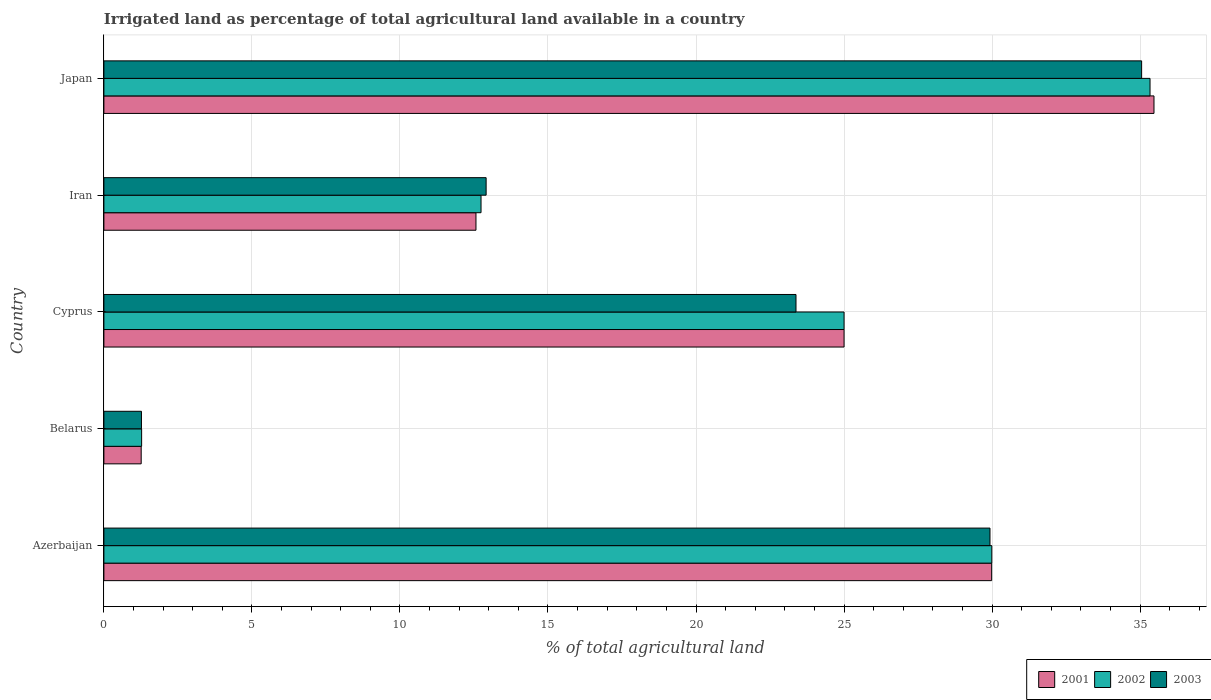How many different coloured bars are there?
Provide a succinct answer. 3. Are the number of bars on each tick of the Y-axis equal?
Provide a succinct answer. Yes. How many bars are there on the 5th tick from the top?
Keep it short and to the point. 3. How many bars are there on the 3rd tick from the bottom?
Your answer should be very brief. 3. What is the label of the 1st group of bars from the top?
Ensure brevity in your answer.  Japan. In how many cases, is the number of bars for a given country not equal to the number of legend labels?
Provide a short and direct response. 0. What is the percentage of irrigated land in 2003 in Iran?
Offer a very short reply. 12.91. Across all countries, what is the maximum percentage of irrigated land in 2002?
Your answer should be compact. 35.33. Across all countries, what is the minimum percentage of irrigated land in 2002?
Provide a succinct answer. 1.27. In which country was the percentage of irrigated land in 2003 minimum?
Give a very brief answer. Belarus. What is the total percentage of irrigated land in 2002 in the graph?
Your response must be concise. 104.34. What is the difference between the percentage of irrigated land in 2001 in Azerbaijan and that in Belarus?
Provide a short and direct response. 28.73. What is the difference between the percentage of irrigated land in 2003 in Belarus and the percentage of irrigated land in 2002 in Iran?
Keep it short and to the point. -11.47. What is the average percentage of irrigated land in 2001 per country?
Your response must be concise. 20.86. In how many countries, is the percentage of irrigated land in 2003 greater than 33 %?
Make the answer very short. 1. What is the ratio of the percentage of irrigated land in 2003 in Iran to that in Japan?
Offer a very short reply. 0.37. Is the difference between the percentage of irrigated land in 2002 in Cyprus and Japan greater than the difference between the percentage of irrigated land in 2001 in Cyprus and Japan?
Provide a succinct answer. Yes. What is the difference between the highest and the second highest percentage of irrigated land in 2002?
Keep it short and to the point. 5.34. What is the difference between the highest and the lowest percentage of irrigated land in 2003?
Your response must be concise. 33.78. In how many countries, is the percentage of irrigated land in 2002 greater than the average percentage of irrigated land in 2002 taken over all countries?
Make the answer very short. 3. What does the 2nd bar from the top in Belarus represents?
Offer a very short reply. 2002. What does the 1st bar from the bottom in Iran represents?
Make the answer very short. 2001. How many bars are there?
Your answer should be very brief. 15. Are all the bars in the graph horizontal?
Your response must be concise. Yes. Are the values on the major ticks of X-axis written in scientific E-notation?
Provide a succinct answer. No. Does the graph contain any zero values?
Make the answer very short. No. How many legend labels are there?
Offer a very short reply. 3. How are the legend labels stacked?
Make the answer very short. Horizontal. What is the title of the graph?
Ensure brevity in your answer.  Irrigated land as percentage of total agricultural land available in a country. What is the label or title of the X-axis?
Your answer should be compact. % of total agricultural land. What is the label or title of the Y-axis?
Ensure brevity in your answer.  Country. What is the % of total agricultural land in 2001 in Azerbaijan?
Your answer should be compact. 29.99. What is the % of total agricultural land in 2002 in Azerbaijan?
Offer a terse response. 29.99. What is the % of total agricultural land in 2003 in Azerbaijan?
Your answer should be very brief. 29.93. What is the % of total agricultural land of 2001 in Belarus?
Offer a very short reply. 1.26. What is the % of total agricultural land in 2002 in Belarus?
Offer a very short reply. 1.27. What is the % of total agricultural land of 2003 in Belarus?
Offer a very short reply. 1.27. What is the % of total agricultural land in 2002 in Cyprus?
Make the answer very short. 25. What is the % of total agricultural land of 2003 in Cyprus?
Your response must be concise. 23.38. What is the % of total agricultural land of 2001 in Iran?
Your answer should be compact. 12.57. What is the % of total agricultural land in 2002 in Iran?
Your answer should be compact. 12.74. What is the % of total agricultural land in 2003 in Iran?
Your answer should be very brief. 12.91. What is the % of total agricultural land of 2001 in Japan?
Provide a short and direct response. 35.47. What is the % of total agricultural land in 2002 in Japan?
Ensure brevity in your answer.  35.33. What is the % of total agricultural land of 2003 in Japan?
Ensure brevity in your answer.  35.05. Across all countries, what is the maximum % of total agricultural land of 2001?
Your answer should be compact. 35.47. Across all countries, what is the maximum % of total agricultural land of 2002?
Your answer should be very brief. 35.33. Across all countries, what is the maximum % of total agricultural land in 2003?
Your answer should be compact. 35.05. Across all countries, what is the minimum % of total agricultural land in 2001?
Your answer should be very brief. 1.26. Across all countries, what is the minimum % of total agricultural land in 2002?
Ensure brevity in your answer.  1.27. Across all countries, what is the minimum % of total agricultural land in 2003?
Make the answer very short. 1.27. What is the total % of total agricultural land of 2001 in the graph?
Keep it short and to the point. 104.28. What is the total % of total agricultural land in 2002 in the graph?
Offer a very short reply. 104.34. What is the total % of total agricultural land of 2003 in the graph?
Your answer should be compact. 102.54. What is the difference between the % of total agricultural land of 2001 in Azerbaijan and that in Belarus?
Provide a succinct answer. 28.73. What is the difference between the % of total agricultural land in 2002 in Azerbaijan and that in Belarus?
Offer a very short reply. 28.72. What is the difference between the % of total agricultural land in 2003 in Azerbaijan and that in Belarus?
Make the answer very short. 28.66. What is the difference between the % of total agricultural land in 2001 in Azerbaijan and that in Cyprus?
Offer a very short reply. 4.99. What is the difference between the % of total agricultural land in 2002 in Azerbaijan and that in Cyprus?
Keep it short and to the point. 4.99. What is the difference between the % of total agricultural land in 2003 in Azerbaijan and that in Cyprus?
Offer a very short reply. 6.55. What is the difference between the % of total agricultural land of 2001 in Azerbaijan and that in Iran?
Provide a succinct answer. 17.42. What is the difference between the % of total agricultural land in 2002 in Azerbaijan and that in Iran?
Offer a very short reply. 17.25. What is the difference between the % of total agricultural land in 2003 in Azerbaijan and that in Iran?
Provide a succinct answer. 17.02. What is the difference between the % of total agricultural land of 2001 in Azerbaijan and that in Japan?
Provide a short and direct response. -5.48. What is the difference between the % of total agricultural land of 2002 in Azerbaijan and that in Japan?
Keep it short and to the point. -5.34. What is the difference between the % of total agricultural land in 2003 in Azerbaijan and that in Japan?
Provide a short and direct response. -5.12. What is the difference between the % of total agricultural land in 2001 in Belarus and that in Cyprus?
Your response must be concise. -23.74. What is the difference between the % of total agricultural land in 2002 in Belarus and that in Cyprus?
Provide a succinct answer. -23.73. What is the difference between the % of total agricultural land of 2003 in Belarus and that in Cyprus?
Offer a terse response. -22.11. What is the difference between the % of total agricultural land in 2001 in Belarus and that in Iran?
Provide a short and direct response. -11.31. What is the difference between the % of total agricultural land of 2002 in Belarus and that in Iran?
Keep it short and to the point. -11.46. What is the difference between the % of total agricultural land in 2003 in Belarus and that in Iran?
Keep it short and to the point. -11.64. What is the difference between the % of total agricultural land of 2001 in Belarus and that in Japan?
Offer a terse response. -34.21. What is the difference between the % of total agricultural land in 2002 in Belarus and that in Japan?
Your answer should be very brief. -34.06. What is the difference between the % of total agricultural land of 2003 in Belarus and that in Japan?
Provide a short and direct response. -33.78. What is the difference between the % of total agricultural land in 2001 in Cyprus and that in Iran?
Provide a short and direct response. 12.43. What is the difference between the % of total agricultural land of 2002 in Cyprus and that in Iran?
Keep it short and to the point. 12.26. What is the difference between the % of total agricultural land of 2003 in Cyprus and that in Iran?
Keep it short and to the point. 10.47. What is the difference between the % of total agricultural land in 2001 in Cyprus and that in Japan?
Your answer should be compact. -10.47. What is the difference between the % of total agricultural land of 2002 in Cyprus and that in Japan?
Provide a succinct answer. -10.33. What is the difference between the % of total agricultural land of 2003 in Cyprus and that in Japan?
Give a very brief answer. -11.67. What is the difference between the % of total agricultural land of 2001 in Iran and that in Japan?
Ensure brevity in your answer.  -22.9. What is the difference between the % of total agricultural land in 2002 in Iran and that in Japan?
Keep it short and to the point. -22.6. What is the difference between the % of total agricultural land of 2003 in Iran and that in Japan?
Your answer should be very brief. -22.14. What is the difference between the % of total agricultural land of 2001 in Azerbaijan and the % of total agricultural land of 2002 in Belarus?
Provide a succinct answer. 28.71. What is the difference between the % of total agricultural land of 2001 in Azerbaijan and the % of total agricultural land of 2003 in Belarus?
Offer a terse response. 28.72. What is the difference between the % of total agricultural land of 2002 in Azerbaijan and the % of total agricultural land of 2003 in Belarus?
Offer a very short reply. 28.72. What is the difference between the % of total agricultural land in 2001 in Azerbaijan and the % of total agricultural land in 2002 in Cyprus?
Give a very brief answer. 4.99. What is the difference between the % of total agricultural land in 2001 in Azerbaijan and the % of total agricultural land in 2003 in Cyprus?
Offer a very short reply. 6.61. What is the difference between the % of total agricultural land of 2002 in Azerbaijan and the % of total agricultural land of 2003 in Cyprus?
Offer a very short reply. 6.61. What is the difference between the % of total agricultural land in 2001 in Azerbaijan and the % of total agricultural land in 2002 in Iran?
Your answer should be very brief. 17.25. What is the difference between the % of total agricultural land of 2001 in Azerbaijan and the % of total agricultural land of 2003 in Iran?
Ensure brevity in your answer.  17.08. What is the difference between the % of total agricultural land in 2002 in Azerbaijan and the % of total agricultural land in 2003 in Iran?
Your response must be concise. 17.08. What is the difference between the % of total agricultural land in 2001 in Azerbaijan and the % of total agricultural land in 2002 in Japan?
Provide a short and direct response. -5.35. What is the difference between the % of total agricultural land in 2001 in Azerbaijan and the % of total agricultural land in 2003 in Japan?
Provide a succinct answer. -5.07. What is the difference between the % of total agricultural land of 2002 in Azerbaijan and the % of total agricultural land of 2003 in Japan?
Your answer should be very brief. -5.06. What is the difference between the % of total agricultural land of 2001 in Belarus and the % of total agricultural land of 2002 in Cyprus?
Your answer should be compact. -23.74. What is the difference between the % of total agricultural land in 2001 in Belarus and the % of total agricultural land in 2003 in Cyprus?
Your answer should be very brief. -22.12. What is the difference between the % of total agricultural land of 2002 in Belarus and the % of total agricultural land of 2003 in Cyprus?
Your answer should be very brief. -22.1. What is the difference between the % of total agricultural land of 2001 in Belarus and the % of total agricultural land of 2002 in Iran?
Provide a short and direct response. -11.48. What is the difference between the % of total agricultural land of 2001 in Belarus and the % of total agricultural land of 2003 in Iran?
Your answer should be compact. -11.65. What is the difference between the % of total agricultural land in 2002 in Belarus and the % of total agricultural land in 2003 in Iran?
Your response must be concise. -11.64. What is the difference between the % of total agricultural land of 2001 in Belarus and the % of total agricultural land of 2002 in Japan?
Your answer should be very brief. -34.08. What is the difference between the % of total agricultural land in 2001 in Belarus and the % of total agricultural land in 2003 in Japan?
Offer a terse response. -33.79. What is the difference between the % of total agricultural land in 2002 in Belarus and the % of total agricultural land in 2003 in Japan?
Provide a short and direct response. -33.78. What is the difference between the % of total agricultural land in 2001 in Cyprus and the % of total agricultural land in 2002 in Iran?
Provide a short and direct response. 12.26. What is the difference between the % of total agricultural land in 2001 in Cyprus and the % of total agricultural land in 2003 in Iran?
Make the answer very short. 12.09. What is the difference between the % of total agricultural land of 2002 in Cyprus and the % of total agricultural land of 2003 in Iran?
Your answer should be compact. 12.09. What is the difference between the % of total agricultural land of 2001 in Cyprus and the % of total agricultural land of 2002 in Japan?
Your answer should be very brief. -10.33. What is the difference between the % of total agricultural land of 2001 in Cyprus and the % of total agricultural land of 2003 in Japan?
Make the answer very short. -10.05. What is the difference between the % of total agricultural land of 2002 in Cyprus and the % of total agricultural land of 2003 in Japan?
Your answer should be very brief. -10.05. What is the difference between the % of total agricultural land of 2001 in Iran and the % of total agricultural land of 2002 in Japan?
Offer a terse response. -22.77. What is the difference between the % of total agricultural land of 2001 in Iran and the % of total agricultural land of 2003 in Japan?
Offer a very short reply. -22.48. What is the difference between the % of total agricultural land in 2002 in Iran and the % of total agricultural land in 2003 in Japan?
Your answer should be compact. -22.31. What is the average % of total agricultural land of 2001 per country?
Your response must be concise. 20.86. What is the average % of total agricultural land in 2002 per country?
Your response must be concise. 20.87. What is the average % of total agricultural land in 2003 per country?
Your response must be concise. 20.51. What is the difference between the % of total agricultural land of 2001 and % of total agricultural land of 2002 in Azerbaijan?
Your answer should be very brief. -0. What is the difference between the % of total agricultural land in 2001 and % of total agricultural land in 2003 in Azerbaijan?
Offer a very short reply. 0.06. What is the difference between the % of total agricultural land in 2002 and % of total agricultural land in 2003 in Azerbaijan?
Provide a succinct answer. 0.06. What is the difference between the % of total agricultural land of 2001 and % of total agricultural land of 2002 in Belarus?
Your answer should be compact. -0.01. What is the difference between the % of total agricultural land in 2001 and % of total agricultural land in 2003 in Belarus?
Your answer should be very brief. -0.01. What is the difference between the % of total agricultural land in 2002 and % of total agricultural land in 2003 in Belarus?
Ensure brevity in your answer.  0.01. What is the difference between the % of total agricultural land of 2001 and % of total agricultural land of 2002 in Cyprus?
Your response must be concise. 0. What is the difference between the % of total agricultural land of 2001 and % of total agricultural land of 2003 in Cyprus?
Give a very brief answer. 1.62. What is the difference between the % of total agricultural land of 2002 and % of total agricultural land of 2003 in Cyprus?
Your answer should be very brief. 1.62. What is the difference between the % of total agricultural land in 2001 and % of total agricultural land in 2002 in Iran?
Offer a very short reply. -0.17. What is the difference between the % of total agricultural land in 2001 and % of total agricultural land in 2003 in Iran?
Provide a succinct answer. -0.34. What is the difference between the % of total agricultural land in 2002 and % of total agricultural land in 2003 in Iran?
Provide a succinct answer. -0.17. What is the difference between the % of total agricultural land in 2001 and % of total agricultural land in 2002 in Japan?
Offer a terse response. 0.13. What is the difference between the % of total agricultural land of 2001 and % of total agricultural land of 2003 in Japan?
Provide a succinct answer. 0.42. What is the difference between the % of total agricultural land of 2002 and % of total agricultural land of 2003 in Japan?
Your answer should be very brief. 0.28. What is the ratio of the % of total agricultural land of 2001 in Azerbaijan to that in Belarus?
Your answer should be compact. 23.8. What is the ratio of the % of total agricultural land of 2002 in Azerbaijan to that in Belarus?
Your response must be concise. 23.54. What is the ratio of the % of total agricultural land of 2003 in Azerbaijan to that in Belarus?
Provide a succinct answer. 23.59. What is the ratio of the % of total agricultural land of 2001 in Azerbaijan to that in Cyprus?
Offer a terse response. 1.2. What is the ratio of the % of total agricultural land of 2002 in Azerbaijan to that in Cyprus?
Keep it short and to the point. 1.2. What is the ratio of the % of total agricultural land of 2003 in Azerbaijan to that in Cyprus?
Your answer should be compact. 1.28. What is the ratio of the % of total agricultural land of 2001 in Azerbaijan to that in Iran?
Make the answer very short. 2.39. What is the ratio of the % of total agricultural land in 2002 in Azerbaijan to that in Iran?
Your answer should be very brief. 2.35. What is the ratio of the % of total agricultural land of 2003 in Azerbaijan to that in Iran?
Provide a short and direct response. 2.32. What is the ratio of the % of total agricultural land in 2001 in Azerbaijan to that in Japan?
Keep it short and to the point. 0.85. What is the ratio of the % of total agricultural land in 2002 in Azerbaijan to that in Japan?
Give a very brief answer. 0.85. What is the ratio of the % of total agricultural land in 2003 in Azerbaijan to that in Japan?
Your answer should be compact. 0.85. What is the ratio of the % of total agricultural land of 2001 in Belarus to that in Cyprus?
Offer a terse response. 0.05. What is the ratio of the % of total agricultural land in 2002 in Belarus to that in Cyprus?
Provide a succinct answer. 0.05. What is the ratio of the % of total agricultural land of 2003 in Belarus to that in Cyprus?
Your response must be concise. 0.05. What is the ratio of the % of total agricultural land of 2001 in Belarus to that in Iran?
Offer a very short reply. 0.1. What is the ratio of the % of total agricultural land of 2002 in Belarus to that in Iran?
Offer a very short reply. 0.1. What is the ratio of the % of total agricultural land in 2003 in Belarus to that in Iran?
Provide a succinct answer. 0.1. What is the ratio of the % of total agricultural land in 2001 in Belarus to that in Japan?
Give a very brief answer. 0.04. What is the ratio of the % of total agricultural land in 2002 in Belarus to that in Japan?
Make the answer very short. 0.04. What is the ratio of the % of total agricultural land of 2003 in Belarus to that in Japan?
Provide a short and direct response. 0.04. What is the ratio of the % of total agricultural land in 2001 in Cyprus to that in Iran?
Give a very brief answer. 1.99. What is the ratio of the % of total agricultural land in 2002 in Cyprus to that in Iran?
Your response must be concise. 1.96. What is the ratio of the % of total agricultural land in 2003 in Cyprus to that in Iran?
Ensure brevity in your answer.  1.81. What is the ratio of the % of total agricultural land of 2001 in Cyprus to that in Japan?
Make the answer very short. 0.7. What is the ratio of the % of total agricultural land in 2002 in Cyprus to that in Japan?
Your answer should be compact. 0.71. What is the ratio of the % of total agricultural land of 2003 in Cyprus to that in Japan?
Offer a terse response. 0.67. What is the ratio of the % of total agricultural land of 2001 in Iran to that in Japan?
Your answer should be very brief. 0.35. What is the ratio of the % of total agricultural land in 2002 in Iran to that in Japan?
Keep it short and to the point. 0.36. What is the ratio of the % of total agricultural land of 2003 in Iran to that in Japan?
Your response must be concise. 0.37. What is the difference between the highest and the second highest % of total agricultural land of 2001?
Keep it short and to the point. 5.48. What is the difference between the highest and the second highest % of total agricultural land of 2002?
Ensure brevity in your answer.  5.34. What is the difference between the highest and the second highest % of total agricultural land of 2003?
Keep it short and to the point. 5.12. What is the difference between the highest and the lowest % of total agricultural land in 2001?
Provide a short and direct response. 34.21. What is the difference between the highest and the lowest % of total agricultural land in 2002?
Ensure brevity in your answer.  34.06. What is the difference between the highest and the lowest % of total agricultural land of 2003?
Keep it short and to the point. 33.78. 